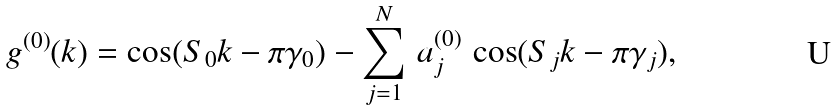Convert formula to latex. <formula><loc_0><loc_0><loc_500><loc_500>g ^ { ( 0 ) } ( k ) = \cos ( S _ { 0 } k - \pi \gamma _ { 0 } ) - \sum _ { j = 1 } ^ { N } \, a _ { j } ^ { ( 0 ) } \, \cos ( S _ { j } k - \pi \gamma _ { j } ) ,</formula> 